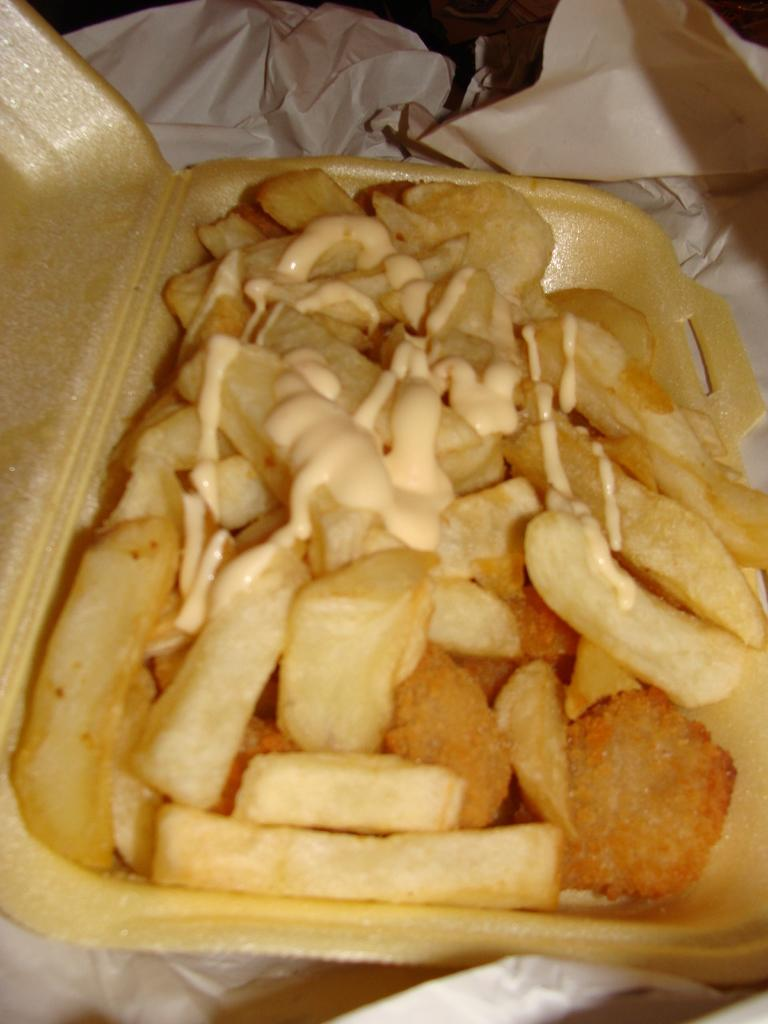What is in the bowl that is visible in the image? There is a bowl with french fries in the image. Where is the bowl located in the image? The bowl is placed on a table. What type of spade is being used to work on the garden in the image? There is no spade or garden present in the image; it features a bowl of french fries on a table. What punishment is being given to the person in the image for not finishing their french fries? There is no indication of punishment in the image; it simply shows a bowl of french fries on a table. 